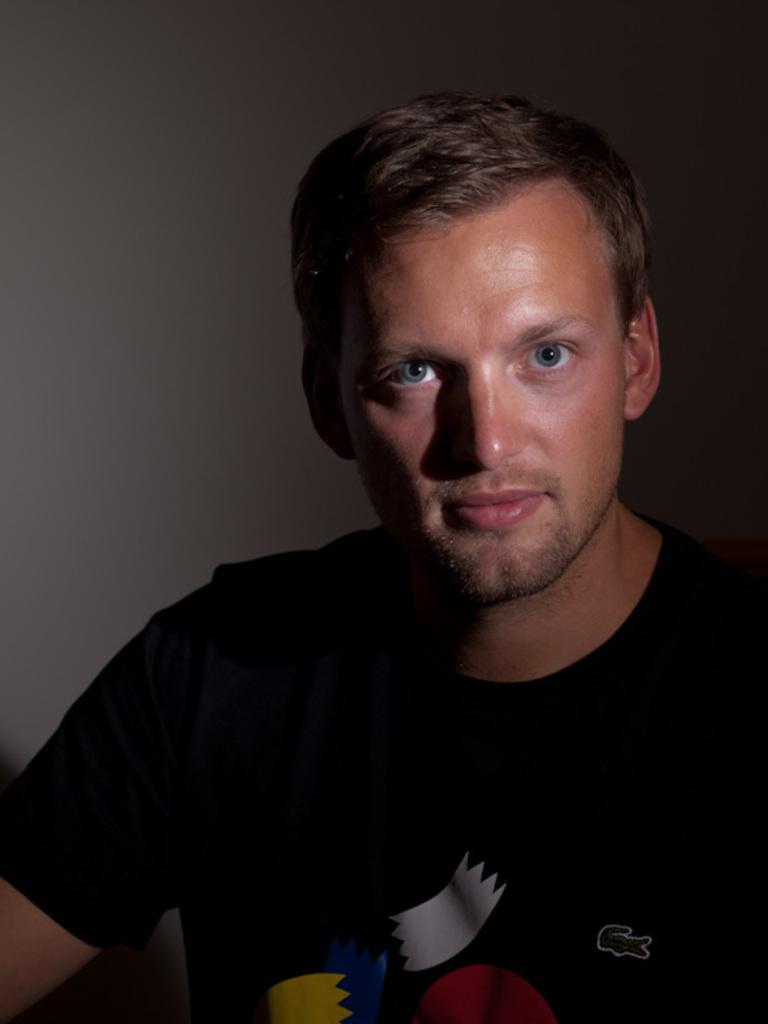Who or what is present in the image? There is a person in the image. What is the person wearing? The person is wearing a black t-shirt. What can be seen in the background of the image? There is a well in the background of the image. What type of note is the person holding in the image? There is no note present in the image. Can you see any wounds on the person in the image? There is no indication of any wounds on the person in the image. What type of teeth does the person have in the image? There is no information about the person's teeth in the image. 